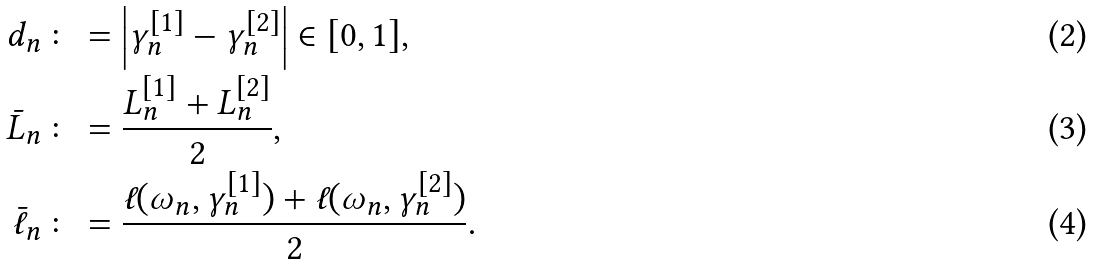Convert formula to latex. <formula><loc_0><loc_0><loc_500><loc_500>d _ { n } & \colon = \left | \gamma _ { n } ^ { [ 1 ] } - \gamma _ { n } ^ { [ 2 ] } \right | \in [ 0 , 1 ] , \\ \bar { L } _ { n } & \colon = \frac { L _ { n } ^ { [ 1 ] } + L _ { n } ^ { [ 2 ] } } { 2 } , \\ \bar { \ell } _ { n } & \colon = \frac { \ell ( \omega _ { n } , \gamma _ { n } ^ { [ 1 ] } ) + \ell ( \omega _ { n } , \gamma _ { n } ^ { [ 2 ] } ) } { 2 } .</formula> 